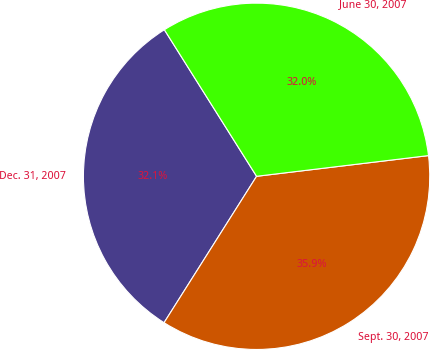Convert chart to OTSL. <chart><loc_0><loc_0><loc_500><loc_500><pie_chart><fcel>Dec. 31, 2007<fcel>Sept. 30, 2007<fcel>June 30, 2007<nl><fcel>32.09%<fcel>35.88%<fcel>32.03%<nl></chart> 